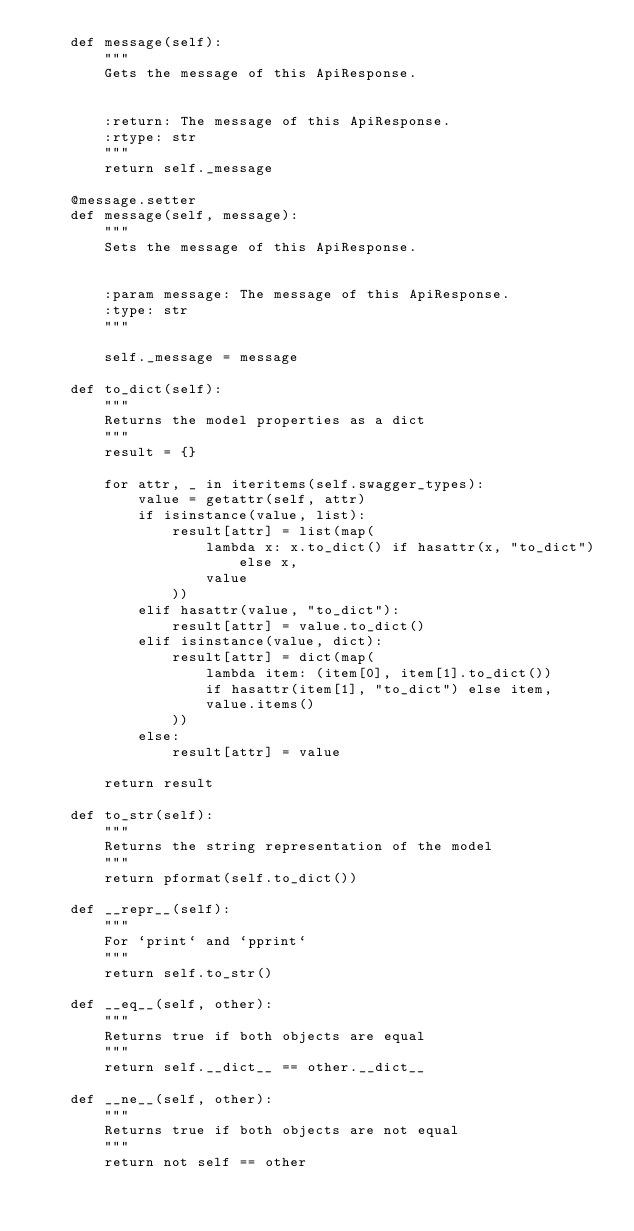<code> <loc_0><loc_0><loc_500><loc_500><_Python_>    def message(self):
        """
        Gets the message of this ApiResponse.


        :return: The message of this ApiResponse.
        :rtype: str
        """
        return self._message

    @message.setter
    def message(self, message):
        """
        Sets the message of this ApiResponse.


        :param message: The message of this ApiResponse.
        :type: str
        """
        
        self._message = message

    def to_dict(self):
        """
        Returns the model properties as a dict
        """
        result = {}

        for attr, _ in iteritems(self.swagger_types):
            value = getattr(self, attr)
            if isinstance(value, list):
                result[attr] = list(map(
                    lambda x: x.to_dict() if hasattr(x, "to_dict") else x,
                    value
                ))
            elif hasattr(value, "to_dict"):
                result[attr] = value.to_dict()
            elif isinstance(value, dict):
                result[attr] = dict(map(
                    lambda item: (item[0], item[1].to_dict())
                    if hasattr(item[1], "to_dict") else item,
                    value.items()
                ))
            else:
                result[attr] = value

        return result

    def to_str(self):
        """
        Returns the string representation of the model
        """
        return pformat(self.to_dict())

    def __repr__(self):
        """
        For `print` and `pprint`
        """
        return self.to_str()

    def __eq__(self, other):
        """
        Returns true if both objects are equal
        """
        return self.__dict__ == other.__dict__

    def __ne__(self, other):
        """
        Returns true if both objects are not equal
        """
        return not self == other

</code> 